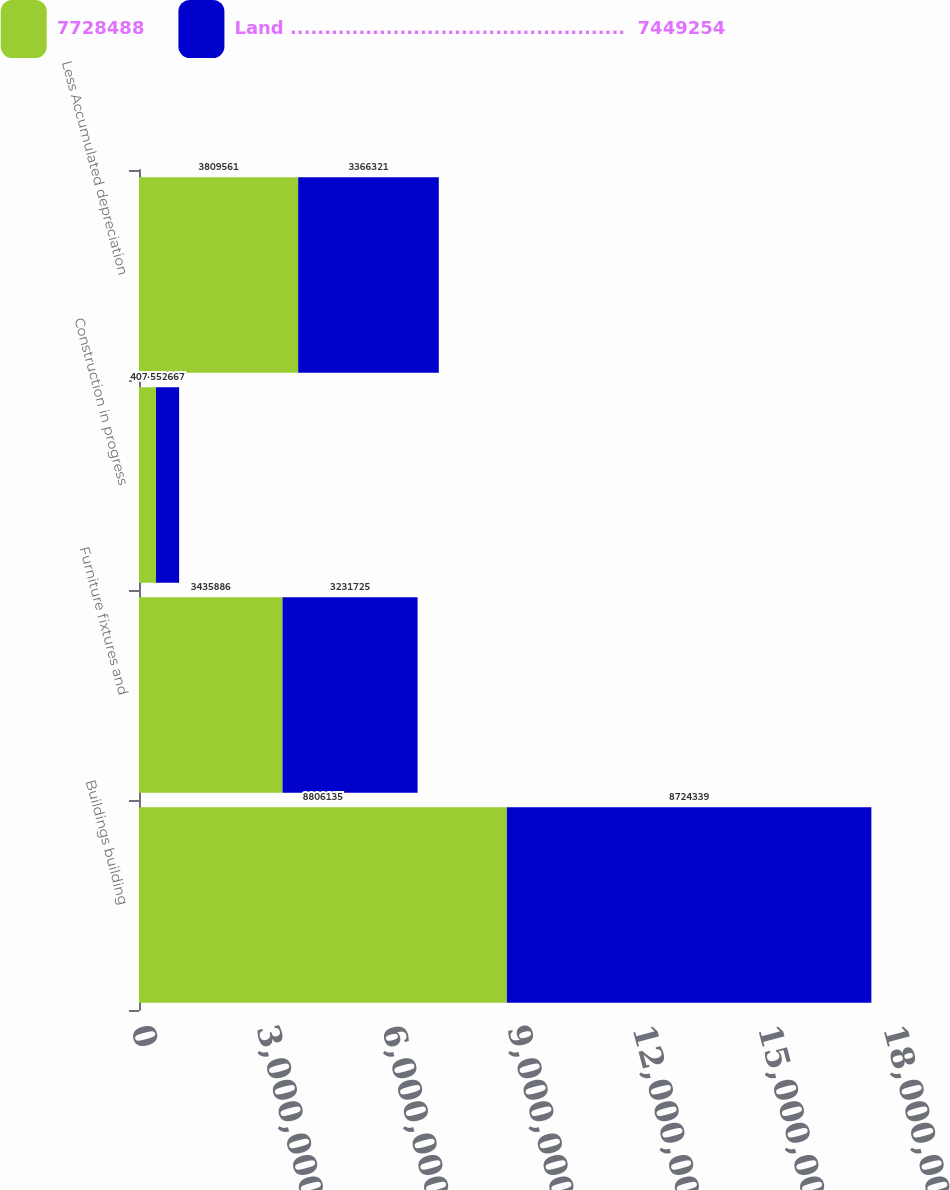<chart> <loc_0><loc_0><loc_500><loc_500><stacked_bar_chart><ecel><fcel>Buildings building<fcel>Furniture fixtures and<fcel>Construction in progress<fcel>Less Accumulated depreciation<nl><fcel>7728488<fcel>8.80614e+06<fcel>3.43589e+06<fcel>407440<fcel>3.80956e+06<nl><fcel>Land .................................................  7449254<fcel>8.72434e+06<fcel>3.23172e+06<fcel>552667<fcel>3.36632e+06<nl></chart> 